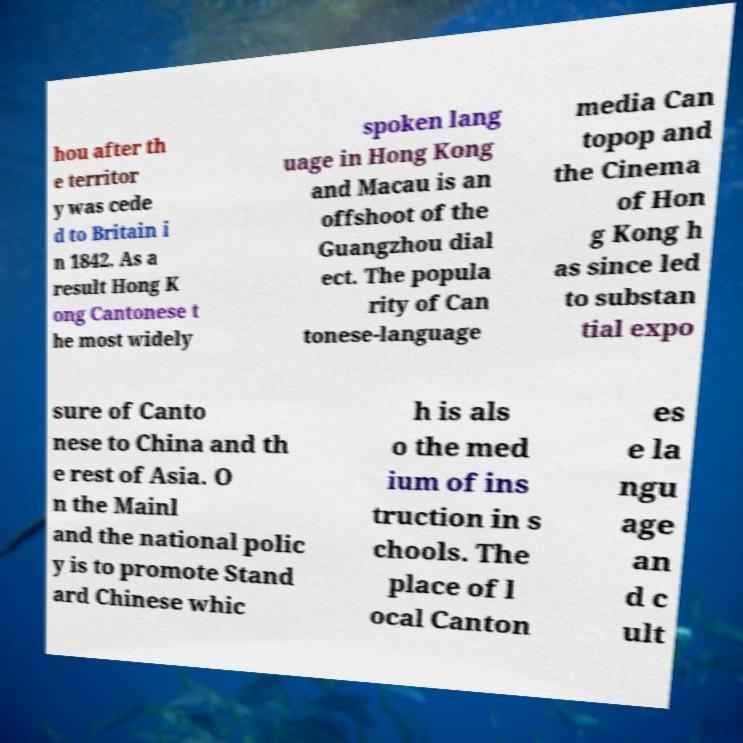There's text embedded in this image that I need extracted. Can you transcribe it verbatim? hou after th e territor y was cede d to Britain i n 1842. As a result Hong K ong Cantonese t he most widely spoken lang uage in Hong Kong and Macau is an offshoot of the Guangzhou dial ect. The popula rity of Can tonese-language media Can topop and the Cinema of Hon g Kong h as since led to substan tial expo sure of Canto nese to China and th e rest of Asia. O n the Mainl and the national polic y is to promote Stand ard Chinese whic h is als o the med ium of ins truction in s chools. The place of l ocal Canton es e la ngu age an d c ult 